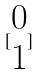<formula> <loc_0><loc_0><loc_500><loc_500>[ \begin{matrix} 0 \\ 1 \end{matrix} ]</formula> 